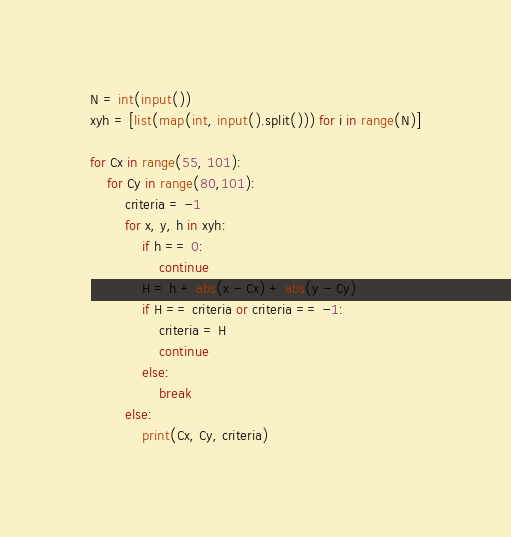Convert code to text. <code><loc_0><loc_0><loc_500><loc_500><_Python_>N = int(input())
xyh = [list(map(int, input().split())) for i in range(N)]

for Cx in range(55, 101):
    for Cy in range(80,101):
        criteria = -1
        for x, y, h in xyh:
            if h == 0:
                continue
            H = h + abs(x - Cx) + abs(y - Cy)
            if H == criteria or criteria == -1:
                criteria = H
                continue
            else:
                break
        else:
            print(Cx, Cy, criteria)
</code> 